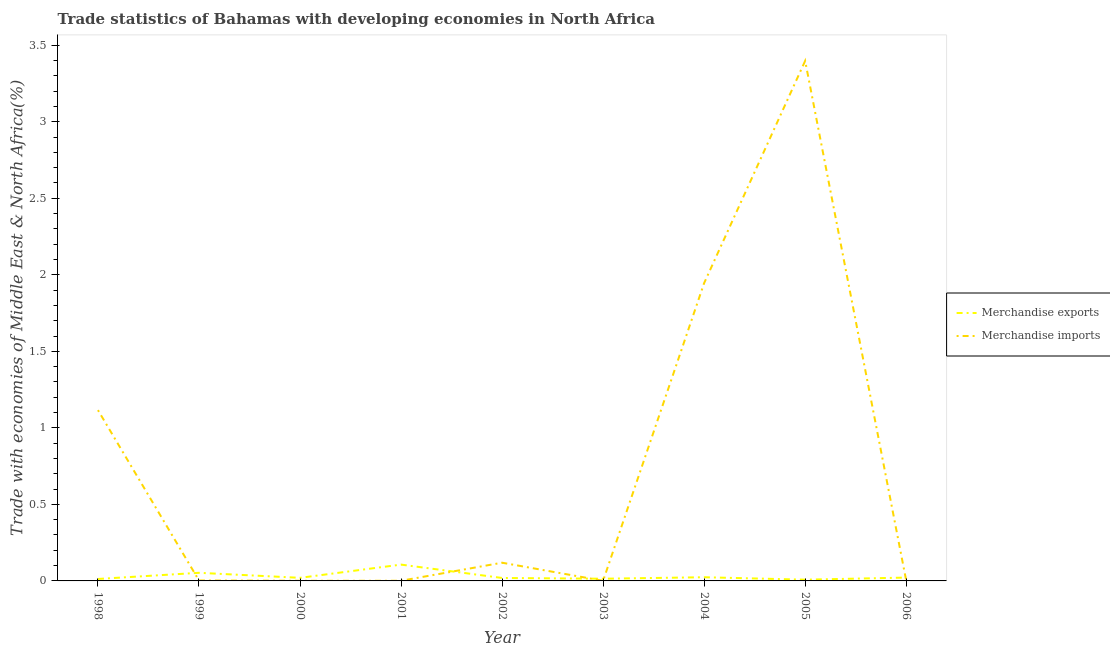How many different coloured lines are there?
Offer a very short reply. 2. What is the merchandise imports in 2002?
Offer a terse response. 0.12. Across all years, what is the maximum merchandise exports?
Your response must be concise. 0.11. Across all years, what is the minimum merchandise exports?
Offer a very short reply. 0.01. In which year was the merchandise exports minimum?
Ensure brevity in your answer.  2005. What is the total merchandise exports in the graph?
Offer a terse response. 0.28. What is the difference between the merchandise exports in 1999 and that in 2004?
Your answer should be very brief. 0.03. What is the difference between the merchandise imports in 1999 and the merchandise exports in 2004?
Keep it short and to the point. -0.02. What is the average merchandise exports per year?
Ensure brevity in your answer.  0.03. In the year 1998, what is the difference between the merchandise exports and merchandise imports?
Your answer should be compact. -1.1. What is the ratio of the merchandise imports in 2003 to that in 2005?
Keep it short and to the point. 0. Is the merchandise exports in 2000 less than that in 2002?
Keep it short and to the point. No. Is the difference between the merchandise imports in 2001 and 2006 greater than the difference between the merchandise exports in 2001 and 2006?
Make the answer very short. No. What is the difference between the highest and the second highest merchandise imports?
Offer a terse response. 1.45. What is the difference between the highest and the lowest merchandise imports?
Provide a short and direct response. 3.4. Does the merchandise exports monotonically increase over the years?
Offer a very short reply. No. Is the merchandise exports strictly greater than the merchandise imports over the years?
Keep it short and to the point. No. Is the merchandise exports strictly less than the merchandise imports over the years?
Make the answer very short. No. Are the values on the major ticks of Y-axis written in scientific E-notation?
Your answer should be compact. No. Does the graph contain any zero values?
Provide a short and direct response. No. How are the legend labels stacked?
Make the answer very short. Vertical. What is the title of the graph?
Provide a succinct answer. Trade statistics of Bahamas with developing economies in North Africa. Does "Private funds" appear as one of the legend labels in the graph?
Make the answer very short. No. What is the label or title of the Y-axis?
Your answer should be very brief. Trade with economies of Middle East & North Africa(%). What is the Trade with economies of Middle East & North Africa(%) of Merchandise exports in 1998?
Keep it short and to the point. 0.01. What is the Trade with economies of Middle East & North Africa(%) in Merchandise imports in 1998?
Provide a succinct answer. 1.12. What is the Trade with economies of Middle East & North Africa(%) of Merchandise exports in 1999?
Your response must be concise. 0.05. What is the Trade with economies of Middle East & North Africa(%) in Merchandise imports in 1999?
Keep it short and to the point. 0. What is the Trade with economies of Middle East & North Africa(%) of Merchandise exports in 2000?
Provide a short and direct response. 0.02. What is the Trade with economies of Middle East & North Africa(%) in Merchandise imports in 2000?
Make the answer very short. 0. What is the Trade with economies of Middle East & North Africa(%) in Merchandise exports in 2001?
Offer a very short reply. 0.11. What is the Trade with economies of Middle East & North Africa(%) of Merchandise imports in 2001?
Give a very brief answer. 0. What is the Trade with economies of Middle East & North Africa(%) in Merchandise exports in 2002?
Make the answer very short. 0.02. What is the Trade with economies of Middle East & North Africa(%) of Merchandise imports in 2002?
Your response must be concise. 0.12. What is the Trade with economies of Middle East & North Africa(%) of Merchandise exports in 2003?
Make the answer very short. 0.01. What is the Trade with economies of Middle East & North Africa(%) in Merchandise imports in 2003?
Provide a succinct answer. 0. What is the Trade with economies of Middle East & North Africa(%) in Merchandise exports in 2004?
Give a very brief answer. 0.02. What is the Trade with economies of Middle East & North Africa(%) in Merchandise imports in 2004?
Provide a short and direct response. 1.95. What is the Trade with economies of Middle East & North Africa(%) of Merchandise exports in 2005?
Make the answer very short. 0.01. What is the Trade with economies of Middle East & North Africa(%) of Merchandise imports in 2005?
Provide a succinct answer. 3.4. What is the Trade with economies of Middle East & North Africa(%) in Merchandise exports in 2006?
Make the answer very short. 0.02. What is the Trade with economies of Middle East & North Africa(%) of Merchandise imports in 2006?
Your response must be concise. 0. Across all years, what is the maximum Trade with economies of Middle East & North Africa(%) in Merchandise exports?
Provide a succinct answer. 0.11. Across all years, what is the maximum Trade with economies of Middle East & North Africa(%) of Merchandise imports?
Your answer should be compact. 3.4. Across all years, what is the minimum Trade with economies of Middle East & North Africa(%) in Merchandise exports?
Your answer should be very brief. 0.01. Across all years, what is the minimum Trade with economies of Middle East & North Africa(%) in Merchandise imports?
Make the answer very short. 0. What is the total Trade with economies of Middle East & North Africa(%) of Merchandise exports in the graph?
Provide a succinct answer. 0.28. What is the total Trade with economies of Middle East & North Africa(%) in Merchandise imports in the graph?
Your answer should be very brief. 6.59. What is the difference between the Trade with economies of Middle East & North Africa(%) in Merchandise exports in 1998 and that in 1999?
Provide a succinct answer. -0.04. What is the difference between the Trade with economies of Middle East & North Africa(%) in Merchandise imports in 1998 and that in 1999?
Keep it short and to the point. 1.11. What is the difference between the Trade with economies of Middle East & North Africa(%) of Merchandise exports in 1998 and that in 2000?
Your answer should be very brief. -0.01. What is the difference between the Trade with economies of Middle East & North Africa(%) in Merchandise imports in 1998 and that in 2000?
Your response must be concise. 1.11. What is the difference between the Trade with economies of Middle East & North Africa(%) in Merchandise exports in 1998 and that in 2001?
Offer a terse response. -0.09. What is the difference between the Trade with economies of Middle East & North Africa(%) of Merchandise imports in 1998 and that in 2001?
Give a very brief answer. 1.11. What is the difference between the Trade with economies of Middle East & North Africa(%) in Merchandise exports in 1998 and that in 2002?
Give a very brief answer. -0.01. What is the difference between the Trade with economies of Middle East & North Africa(%) of Merchandise exports in 1998 and that in 2003?
Offer a terse response. -0. What is the difference between the Trade with economies of Middle East & North Africa(%) in Merchandise imports in 1998 and that in 2003?
Your answer should be very brief. 1.11. What is the difference between the Trade with economies of Middle East & North Africa(%) of Merchandise exports in 1998 and that in 2004?
Provide a succinct answer. -0.01. What is the difference between the Trade with economies of Middle East & North Africa(%) in Merchandise imports in 1998 and that in 2004?
Make the answer very short. -0.83. What is the difference between the Trade with economies of Middle East & North Africa(%) in Merchandise exports in 1998 and that in 2005?
Keep it short and to the point. 0. What is the difference between the Trade with economies of Middle East & North Africa(%) in Merchandise imports in 1998 and that in 2005?
Offer a very short reply. -2.28. What is the difference between the Trade with economies of Middle East & North Africa(%) in Merchandise exports in 1998 and that in 2006?
Provide a succinct answer. -0.01. What is the difference between the Trade with economies of Middle East & North Africa(%) of Merchandise imports in 1998 and that in 2006?
Give a very brief answer. 1.11. What is the difference between the Trade with economies of Middle East & North Africa(%) in Merchandise exports in 1999 and that in 2000?
Your response must be concise. 0.03. What is the difference between the Trade with economies of Middle East & North Africa(%) of Merchandise imports in 1999 and that in 2000?
Offer a very short reply. 0. What is the difference between the Trade with economies of Middle East & North Africa(%) of Merchandise exports in 1999 and that in 2001?
Keep it short and to the point. -0.05. What is the difference between the Trade with economies of Middle East & North Africa(%) in Merchandise imports in 1999 and that in 2001?
Offer a terse response. 0. What is the difference between the Trade with economies of Middle East & North Africa(%) in Merchandise exports in 1999 and that in 2002?
Give a very brief answer. 0.03. What is the difference between the Trade with economies of Middle East & North Africa(%) in Merchandise imports in 1999 and that in 2002?
Keep it short and to the point. -0.12. What is the difference between the Trade with economies of Middle East & North Africa(%) in Merchandise exports in 1999 and that in 2003?
Keep it short and to the point. 0.04. What is the difference between the Trade with economies of Middle East & North Africa(%) of Merchandise imports in 1999 and that in 2003?
Your answer should be compact. 0. What is the difference between the Trade with economies of Middle East & North Africa(%) of Merchandise exports in 1999 and that in 2004?
Ensure brevity in your answer.  0.03. What is the difference between the Trade with economies of Middle East & North Africa(%) in Merchandise imports in 1999 and that in 2004?
Offer a very short reply. -1.94. What is the difference between the Trade with economies of Middle East & North Africa(%) of Merchandise exports in 1999 and that in 2005?
Provide a succinct answer. 0.04. What is the difference between the Trade with economies of Middle East & North Africa(%) of Merchandise imports in 1999 and that in 2005?
Make the answer very short. -3.39. What is the difference between the Trade with economies of Middle East & North Africa(%) in Merchandise exports in 1999 and that in 2006?
Give a very brief answer. 0.03. What is the difference between the Trade with economies of Middle East & North Africa(%) in Merchandise imports in 1999 and that in 2006?
Offer a terse response. -0. What is the difference between the Trade with economies of Middle East & North Africa(%) in Merchandise exports in 2000 and that in 2001?
Ensure brevity in your answer.  -0.09. What is the difference between the Trade with economies of Middle East & North Africa(%) in Merchandise imports in 2000 and that in 2001?
Provide a short and direct response. 0. What is the difference between the Trade with economies of Middle East & North Africa(%) of Merchandise exports in 2000 and that in 2002?
Your answer should be very brief. 0. What is the difference between the Trade with economies of Middle East & North Africa(%) in Merchandise imports in 2000 and that in 2002?
Keep it short and to the point. -0.12. What is the difference between the Trade with economies of Middle East & North Africa(%) of Merchandise exports in 2000 and that in 2003?
Offer a terse response. 0.01. What is the difference between the Trade with economies of Middle East & North Africa(%) of Merchandise imports in 2000 and that in 2003?
Give a very brief answer. 0. What is the difference between the Trade with economies of Middle East & North Africa(%) in Merchandise exports in 2000 and that in 2004?
Give a very brief answer. -0. What is the difference between the Trade with economies of Middle East & North Africa(%) in Merchandise imports in 2000 and that in 2004?
Your answer should be compact. -1.94. What is the difference between the Trade with economies of Middle East & North Africa(%) in Merchandise exports in 2000 and that in 2005?
Give a very brief answer. 0.01. What is the difference between the Trade with economies of Middle East & North Africa(%) of Merchandise imports in 2000 and that in 2005?
Offer a terse response. -3.4. What is the difference between the Trade with economies of Middle East & North Africa(%) of Merchandise exports in 2000 and that in 2006?
Provide a succinct answer. -0. What is the difference between the Trade with economies of Middle East & North Africa(%) in Merchandise imports in 2000 and that in 2006?
Your response must be concise. -0. What is the difference between the Trade with economies of Middle East & North Africa(%) in Merchandise exports in 2001 and that in 2002?
Your answer should be compact. 0.09. What is the difference between the Trade with economies of Middle East & North Africa(%) of Merchandise imports in 2001 and that in 2002?
Provide a short and direct response. -0.12. What is the difference between the Trade with economies of Middle East & North Africa(%) of Merchandise exports in 2001 and that in 2003?
Ensure brevity in your answer.  0.09. What is the difference between the Trade with economies of Middle East & North Africa(%) of Merchandise imports in 2001 and that in 2003?
Your response must be concise. 0. What is the difference between the Trade with economies of Middle East & North Africa(%) of Merchandise exports in 2001 and that in 2004?
Make the answer very short. 0.08. What is the difference between the Trade with economies of Middle East & North Africa(%) of Merchandise imports in 2001 and that in 2004?
Make the answer very short. -1.94. What is the difference between the Trade with economies of Middle East & North Africa(%) of Merchandise exports in 2001 and that in 2005?
Your response must be concise. 0.1. What is the difference between the Trade with economies of Middle East & North Africa(%) of Merchandise imports in 2001 and that in 2005?
Provide a succinct answer. -3.4. What is the difference between the Trade with economies of Middle East & North Africa(%) in Merchandise exports in 2001 and that in 2006?
Keep it short and to the point. 0.08. What is the difference between the Trade with economies of Middle East & North Africa(%) in Merchandise imports in 2001 and that in 2006?
Your answer should be compact. -0. What is the difference between the Trade with economies of Middle East & North Africa(%) in Merchandise exports in 2002 and that in 2003?
Your answer should be compact. 0. What is the difference between the Trade with economies of Middle East & North Africa(%) in Merchandise imports in 2002 and that in 2003?
Your answer should be very brief. 0.12. What is the difference between the Trade with economies of Middle East & North Africa(%) of Merchandise exports in 2002 and that in 2004?
Your answer should be very brief. -0. What is the difference between the Trade with economies of Middle East & North Africa(%) in Merchandise imports in 2002 and that in 2004?
Offer a terse response. -1.83. What is the difference between the Trade with economies of Middle East & North Africa(%) of Merchandise exports in 2002 and that in 2005?
Offer a very short reply. 0.01. What is the difference between the Trade with economies of Middle East & North Africa(%) of Merchandise imports in 2002 and that in 2005?
Your answer should be compact. -3.28. What is the difference between the Trade with economies of Middle East & North Africa(%) of Merchandise exports in 2002 and that in 2006?
Ensure brevity in your answer.  -0. What is the difference between the Trade with economies of Middle East & North Africa(%) of Merchandise imports in 2002 and that in 2006?
Give a very brief answer. 0.12. What is the difference between the Trade with economies of Middle East & North Africa(%) in Merchandise exports in 2003 and that in 2004?
Keep it short and to the point. -0.01. What is the difference between the Trade with economies of Middle East & North Africa(%) of Merchandise imports in 2003 and that in 2004?
Your response must be concise. -1.94. What is the difference between the Trade with economies of Middle East & North Africa(%) in Merchandise exports in 2003 and that in 2005?
Offer a terse response. 0.01. What is the difference between the Trade with economies of Middle East & North Africa(%) of Merchandise imports in 2003 and that in 2005?
Your response must be concise. -3.4. What is the difference between the Trade with economies of Middle East & North Africa(%) of Merchandise exports in 2003 and that in 2006?
Your response must be concise. -0.01. What is the difference between the Trade with economies of Middle East & North Africa(%) in Merchandise imports in 2003 and that in 2006?
Offer a terse response. -0. What is the difference between the Trade with economies of Middle East & North Africa(%) in Merchandise exports in 2004 and that in 2005?
Provide a succinct answer. 0.02. What is the difference between the Trade with economies of Middle East & North Africa(%) in Merchandise imports in 2004 and that in 2005?
Your answer should be very brief. -1.45. What is the difference between the Trade with economies of Middle East & North Africa(%) of Merchandise exports in 2004 and that in 2006?
Offer a terse response. 0. What is the difference between the Trade with economies of Middle East & North Africa(%) of Merchandise imports in 2004 and that in 2006?
Provide a succinct answer. 1.94. What is the difference between the Trade with economies of Middle East & North Africa(%) of Merchandise exports in 2005 and that in 2006?
Give a very brief answer. -0.01. What is the difference between the Trade with economies of Middle East & North Africa(%) of Merchandise imports in 2005 and that in 2006?
Your answer should be compact. 3.39. What is the difference between the Trade with economies of Middle East & North Africa(%) in Merchandise exports in 1998 and the Trade with economies of Middle East & North Africa(%) in Merchandise imports in 1999?
Keep it short and to the point. 0.01. What is the difference between the Trade with economies of Middle East & North Africa(%) in Merchandise exports in 1998 and the Trade with economies of Middle East & North Africa(%) in Merchandise imports in 2000?
Ensure brevity in your answer.  0.01. What is the difference between the Trade with economies of Middle East & North Africa(%) of Merchandise exports in 1998 and the Trade with economies of Middle East & North Africa(%) of Merchandise imports in 2001?
Your answer should be compact. 0.01. What is the difference between the Trade with economies of Middle East & North Africa(%) of Merchandise exports in 1998 and the Trade with economies of Middle East & North Africa(%) of Merchandise imports in 2002?
Provide a succinct answer. -0.11. What is the difference between the Trade with economies of Middle East & North Africa(%) of Merchandise exports in 1998 and the Trade with economies of Middle East & North Africa(%) of Merchandise imports in 2003?
Provide a succinct answer. 0.01. What is the difference between the Trade with economies of Middle East & North Africa(%) of Merchandise exports in 1998 and the Trade with economies of Middle East & North Africa(%) of Merchandise imports in 2004?
Your answer should be compact. -1.93. What is the difference between the Trade with economies of Middle East & North Africa(%) of Merchandise exports in 1998 and the Trade with economies of Middle East & North Africa(%) of Merchandise imports in 2005?
Offer a very short reply. -3.38. What is the difference between the Trade with economies of Middle East & North Africa(%) in Merchandise exports in 1998 and the Trade with economies of Middle East & North Africa(%) in Merchandise imports in 2006?
Keep it short and to the point. 0.01. What is the difference between the Trade with economies of Middle East & North Africa(%) of Merchandise exports in 1999 and the Trade with economies of Middle East & North Africa(%) of Merchandise imports in 2000?
Give a very brief answer. 0.05. What is the difference between the Trade with economies of Middle East & North Africa(%) of Merchandise exports in 1999 and the Trade with economies of Middle East & North Africa(%) of Merchandise imports in 2001?
Keep it short and to the point. 0.05. What is the difference between the Trade with economies of Middle East & North Africa(%) of Merchandise exports in 1999 and the Trade with economies of Middle East & North Africa(%) of Merchandise imports in 2002?
Offer a very short reply. -0.07. What is the difference between the Trade with economies of Middle East & North Africa(%) of Merchandise exports in 1999 and the Trade with economies of Middle East & North Africa(%) of Merchandise imports in 2003?
Your response must be concise. 0.05. What is the difference between the Trade with economies of Middle East & North Africa(%) of Merchandise exports in 1999 and the Trade with economies of Middle East & North Africa(%) of Merchandise imports in 2004?
Provide a succinct answer. -1.89. What is the difference between the Trade with economies of Middle East & North Africa(%) in Merchandise exports in 1999 and the Trade with economies of Middle East & North Africa(%) in Merchandise imports in 2005?
Offer a very short reply. -3.34. What is the difference between the Trade with economies of Middle East & North Africa(%) of Merchandise exports in 1999 and the Trade with economies of Middle East & North Africa(%) of Merchandise imports in 2006?
Offer a terse response. 0.05. What is the difference between the Trade with economies of Middle East & North Africa(%) of Merchandise exports in 2000 and the Trade with economies of Middle East & North Africa(%) of Merchandise imports in 2001?
Keep it short and to the point. 0.02. What is the difference between the Trade with economies of Middle East & North Africa(%) in Merchandise exports in 2000 and the Trade with economies of Middle East & North Africa(%) in Merchandise imports in 2002?
Give a very brief answer. -0.1. What is the difference between the Trade with economies of Middle East & North Africa(%) in Merchandise exports in 2000 and the Trade with economies of Middle East & North Africa(%) in Merchandise imports in 2003?
Offer a very short reply. 0.02. What is the difference between the Trade with economies of Middle East & North Africa(%) of Merchandise exports in 2000 and the Trade with economies of Middle East & North Africa(%) of Merchandise imports in 2004?
Keep it short and to the point. -1.93. What is the difference between the Trade with economies of Middle East & North Africa(%) in Merchandise exports in 2000 and the Trade with economies of Middle East & North Africa(%) in Merchandise imports in 2005?
Provide a short and direct response. -3.38. What is the difference between the Trade with economies of Middle East & North Africa(%) in Merchandise exports in 2000 and the Trade with economies of Middle East & North Africa(%) in Merchandise imports in 2006?
Your answer should be compact. 0.02. What is the difference between the Trade with economies of Middle East & North Africa(%) of Merchandise exports in 2001 and the Trade with economies of Middle East & North Africa(%) of Merchandise imports in 2002?
Offer a terse response. -0.01. What is the difference between the Trade with economies of Middle East & North Africa(%) of Merchandise exports in 2001 and the Trade with economies of Middle East & North Africa(%) of Merchandise imports in 2003?
Your answer should be very brief. 0.11. What is the difference between the Trade with economies of Middle East & North Africa(%) in Merchandise exports in 2001 and the Trade with economies of Middle East & North Africa(%) in Merchandise imports in 2004?
Make the answer very short. -1.84. What is the difference between the Trade with economies of Middle East & North Africa(%) of Merchandise exports in 2001 and the Trade with economies of Middle East & North Africa(%) of Merchandise imports in 2005?
Keep it short and to the point. -3.29. What is the difference between the Trade with economies of Middle East & North Africa(%) of Merchandise exports in 2001 and the Trade with economies of Middle East & North Africa(%) of Merchandise imports in 2006?
Keep it short and to the point. 0.1. What is the difference between the Trade with economies of Middle East & North Africa(%) of Merchandise exports in 2002 and the Trade with economies of Middle East & North Africa(%) of Merchandise imports in 2003?
Provide a succinct answer. 0.02. What is the difference between the Trade with economies of Middle East & North Africa(%) in Merchandise exports in 2002 and the Trade with economies of Middle East & North Africa(%) in Merchandise imports in 2004?
Your answer should be very brief. -1.93. What is the difference between the Trade with economies of Middle East & North Africa(%) of Merchandise exports in 2002 and the Trade with economies of Middle East & North Africa(%) of Merchandise imports in 2005?
Offer a terse response. -3.38. What is the difference between the Trade with economies of Middle East & North Africa(%) in Merchandise exports in 2002 and the Trade with economies of Middle East & North Africa(%) in Merchandise imports in 2006?
Provide a succinct answer. 0.02. What is the difference between the Trade with economies of Middle East & North Africa(%) in Merchandise exports in 2003 and the Trade with economies of Middle East & North Africa(%) in Merchandise imports in 2004?
Provide a short and direct response. -1.93. What is the difference between the Trade with economies of Middle East & North Africa(%) of Merchandise exports in 2003 and the Trade with economies of Middle East & North Africa(%) of Merchandise imports in 2005?
Offer a very short reply. -3.38. What is the difference between the Trade with economies of Middle East & North Africa(%) in Merchandise exports in 2003 and the Trade with economies of Middle East & North Africa(%) in Merchandise imports in 2006?
Keep it short and to the point. 0.01. What is the difference between the Trade with economies of Middle East & North Africa(%) in Merchandise exports in 2004 and the Trade with economies of Middle East & North Africa(%) in Merchandise imports in 2005?
Your answer should be compact. -3.37. What is the difference between the Trade with economies of Middle East & North Africa(%) in Merchandise exports in 2004 and the Trade with economies of Middle East & North Africa(%) in Merchandise imports in 2006?
Offer a very short reply. 0.02. What is the difference between the Trade with economies of Middle East & North Africa(%) in Merchandise exports in 2005 and the Trade with economies of Middle East & North Africa(%) in Merchandise imports in 2006?
Your answer should be compact. 0.01. What is the average Trade with economies of Middle East & North Africa(%) of Merchandise exports per year?
Your response must be concise. 0.03. What is the average Trade with economies of Middle East & North Africa(%) in Merchandise imports per year?
Offer a very short reply. 0.73. In the year 1998, what is the difference between the Trade with economies of Middle East & North Africa(%) of Merchandise exports and Trade with economies of Middle East & North Africa(%) of Merchandise imports?
Offer a very short reply. -1.1. In the year 1999, what is the difference between the Trade with economies of Middle East & North Africa(%) in Merchandise exports and Trade with economies of Middle East & North Africa(%) in Merchandise imports?
Give a very brief answer. 0.05. In the year 2000, what is the difference between the Trade with economies of Middle East & North Africa(%) in Merchandise exports and Trade with economies of Middle East & North Africa(%) in Merchandise imports?
Your answer should be compact. 0.02. In the year 2001, what is the difference between the Trade with economies of Middle East & North Africa(%) in Merchandise exports and Trade with economies of Middle East & North Africa(%) in Merchandise imports?
Ensure brevity in your answer.  0.11. In the year 2002, what is the difference between the Trade with economies of Middle East & North Africa(%) in Merchandise exports and Trade with economies of Middle East & North Africa(%) in Merchandise imports?
Provide a succinct answer. -0.1. In the year 2003, what is the difference between the Trade with economies of Middle East & North Africa(%) of Merchandise exports and Trade with economies of Middle East & North Africa(%) of Merchandise imports?
Ensure brevity in your answer.  0.01. In the year 2004, what is the difference between the Trade with economies of Middle East & North Africa(%) in Merchandise exports and Trade with economies of Middle East & North Africa(%) in Merchandise imports?
Offer a very short reply. -1.92. In the year 2005, what is the difference between the Trade with economies of Middle East & North Africa(%) of Merchandise exports and Trade with economies of Middle East & North Africa(%) of Merchandise imports?
Provide a short and direct response. -3.39. In the year 2006, what is the difference between the Trade with economies of Middle East & North Africa(%) of Merchandise exports and Trade with economies of Middle East & North Africa(%) of Merchandise imports?
Your answer should be very brief. 0.02. What is the ratio of the Trade with economies of Middle East & North Africa(%) in Merchandise exports in 1998 to that in 1999?
Your response must be concise. 0.24. What is the ratio of the Trade with economies of Middle East & North Africa(%) in Merchandise imports in 1998 to that in 1999?
Your answer should be very brief. 386.59. What is the ratio of the Trade with economies of Middle East & North Africa(%) of Merchandise exports in 1998 to that in 2000?
Keep it short and to the point. 0.63. What is the ratio of the Trade with economies of Middle East & North Africa(%) in Merchandise imports in 1998 to that in 2000?
Your response must be concise. 1082.91. What is the ratio of the Trade with economies of Middle East & North Africa(%) in Merchandise exports in 1998 to that in 2001?
Your response must be concise. 0.12. What is the ratio of the Trade with economies of Middle East & North Africa(%) of Merchandise imports in 1998 to that in 2001?
Offer a terse response. 1092.65. What is the ratio of the Trade with economies of Middle East & North Africa(%) in Merchandise exports in 1998 to that in 2002?
Your answer should be compact. 0.66. What is the ratio of the Trade with economies of Middle East & North Africa(%) in Merchandise imports in 1998 to that in 2002?
Provide a succinct answer. 9.37. What is the ratio of the Trade with economies of Middle East & North Africa(%) of Merchandise exports in 1998 to that in 2003?
Provide a short and direct response. 0.89. What is the ratio of the Trade with economies of Middle East & North Africa(%) in Merchandise imports in 1998 to that in 2003?
Keep it short and to the point. 1392.96. What is the ratio of the Trade with economies of Middle East & North Africa(%) in Merchandise exports in 1998 to that in 2004?
Offer a very short reply. 0.53. What is the ratio of the Trade with economies of Middle East & North Africa(%) in Merchandise imports in 1998 to that in 2004?
Offer a very short reply. 0.57. What is the ratio of the Trade with economies of Middle East & North Africa(%) in Merchandise exports in 1998 to that in 2005?
Keep it short and to the point. 1.57. What is the ratio of the Trade with economies of Middle East & North Africa(%) in Merchandise imports in 1998 to that in 2005?
Keep it short and to the point. 0.33. What is the ratio of the Trade with economies of Middle East & North Africa(%) of Merchandise exports in 1998 to that in 2006?
Give a very brief answer. 0.59. What is the ratio of the Trade with economies of Middle East & North Africa(%) of Merchandise imports in 1998 to that in 2006?
Provide a succinct answer. 374.2. What is the ratio of the Trade with economies of Middle East & North Africa(%) of Merchandise exports in 1999 to that in 2000?
Keep it short and to the point. 2.63. What is the ratio of the Trade with economies of Middle East & North Africa(%) in Merchandise imports in 1999 to that in 2000?
Offer a terse response. 2.8. What is the ratio of the Trade with economies of Middle East & North Africa(%) in Merchandise exports in 1999 to that in 2001?
Provide a short and direct response. 0.5. What is the ratio of the Trade with economies of Middle East & North Africa(%) in Merchandise imports in 1999 to that in 2001?
Give a very brief answer. 2.83. What is the ratio of the Trade with economies of Middle East & North Africa(%) in Merchandise exports in 1999 to that in 2002?
Provide a succinct answer. 2.75. What is the ratio of the Trade with economies of Middle East & North Africa(%) of Merchandise imports in 1999 to that in 2002?
Offer a terse response. 0.02. What is the ratio of the Trade with economies of Middle East & North Africa(%) in Merchandise exports in 1999 to that in 2003?
Your answer should be very brief. 3.7. What is the ratio of the Trade with economies of Middle East & North Africa(%) in Merchandise imports in 1999 to that in 2003?
Your answer should be very brief. 3.6. What is the ratio of the Trade with economies of Middle East & North Africa(%) of Merchandise exports in 1999 to that in 2004?
Your answer should be very brief. 2.2. What is the ratio of the Trade with economies of Middle East & North Africa(%) in Merchandise imports in 1999 to that in 2004?
Your answer should be very brief. 0. What is the ratio of the Trade with economies of Middle East & North Africa(%) of Merchandise exports in 1999 to that in 2005?
Keep it short and to the point. 6.51. What is the ratio of the Trade with economies of Middle East & North Africa(%) of Merchandise imports in 1999 to that in 2005?
Your response must be concise. 0. What is the ratio of the Trade with economies of Middle East & North Africa(%) of Merchandise exports in 1999 to that in 2006?
Offer a very short reply. 2.43. What is the ratio of the Trade with economies of Middle East & North Africa(%) of Merchandise imports in 1999 to that in 2006?
Make the answer very short. 0.97. What is the ratio of the Trade with economies of Middle East & North Africa(%) of Merchandise exports in 2000 to that in 2001?
Keep it short and to the point. 0.19. What is the ratio of the Trade with economies of Middle East & North Africa(%) in Merchandise imports in 2000 to that in 2001?
Keep it short and to the point. 1.01. What is the ratio of the Trade with economies of Middle East & North Africa(%) of Merchandise exports in 2000 to that in 2002?
Offer a very short reply. 1.05. What is the ratio of the Trade with economies of Middle East & North Africa(%) of Merchandise imports in 2000 to that in 2002?
Offer a very short reply. 0.01. What is the ratio of the Trade with economies of Middle East & North Africa(%) in Merchandise exports in 2000 to that in 2003?
Provide a succinct answer. 1.41. What is the ratio of the Trade with economies of Middle East & North Africa(%) of Merchandise imports in 2000 to that in 2003?
Provide a short and direct response. 1.29. What is the ratio of the Trade with economies of Middle East & North Africa(%) in Merchandise exports in 2000 to that in 2004?
Give a very brief answer. 0.84. What is the ratio of the Trade with economies of Middle East & North Africa(%) of Merchandise imports in 2000 to that in 2004?
Give a very brief answer. 0. What is the ratio of the Trade with economies of Middle East & North Africa(%) of Merchandise exports in 2000 to that in 2005?
Your answer should be very brief. 2.48. What is the ratio of the Trade with economies of Middle East & North Africa(%) of Merchandise exports in 2000 to that in 2006?
Ensure brevity in your answer.  0.93. What is the ratio of the Trade with economies of Middle East & North Africa(%) in Merchandise imports in 2000 to that in 2006?
Make the answer very short. 0.35. What is the ratio of the Trade with economies of Middle East & North Africa(%) in Merchandise exports in 2001 to that in 2002?
Offer a very short reply. 5.53. What is the ratio of the Trade with economies of Middle East & North Africa(%) in Merchandise imports in 2001 to that in 2002?
Your response must be concise. 0.01. What is the ratio of the Trade with economies of Middle East & North Africa(%) of Merchandise exports in 2001 to that in 2003?
Your answer should be compact. 7.43. What is the ratio of the Trade with economies of Middle East & North Africa(%) in Merchandise imports in 2001 to that in 2003?
Provide a succinct answer. 1.27. What is the ratio of the Trade with economies of Middle East & North Africa(%) in Merchandise exports in 2001 to that in 2004?
Provide a succinct answer. 4.43. What is the ratio of the Trade with economies of Middle East & North Africa(%) in Merchandise exports in 2001 to that in 2005?
Give a very brief answer. 13.08. What is the ratio of the Trade with economies of Middle East & North Africa(%) of Merchandise imports in 2001 to that in 2005?
Provide a short and direct response. 0. What is the ratio of the Trade with economies of Middle East & North Africa(%) of Merchandise exports in 2001 to that in 2006?
Ensure brevity in your answer.  4.89. What is the ratio of the Trade with economies of Middle East & North Africa(%) in Merchandise imports in 2001 to that in 2006?
Your answer should be compact. 0.34. What is the ratio of the Trade with economies of Middle East & North Africa(%) of Merchandise exports in 2002 to that in 2003?
Provide a short and direct response. 1.34. What is the ratio of the Trade with economies of Middle East & North Africa(%) in Merchandise imports in 2002 to that in 2003?
Keep it short and to the point. 148.63. What is the ratio of the Trade with economies of Middle East & North Africa(%) of Merchandise exports in 2002 to that in 2004?
Provide a succinct answer. 0.8. What is the ratio of the Trade with economies of Middle East & North Africa(%) of Merchandise imports in 2002 to that in 2004?
Make the answer very short. 0.06. What is the ratio of the Trade with economies of Middle East & North Africa(%) in Merchandise exports in 2002 to that in 2005?
Provide a succinct answer. 2.37. What is the ratio of the Trade with economies of Middle East & North Africa(%) in Merchandise imports in 2002 to that in 2005?
Your answer should be compact. 0.04. What is the ratio of the Trade with economies of Middle East & North Africa(%) of Merchandise exports in 2002 to that in 2006?
Your response must be concise. 0.88. What is the ratio of the Trade with economies of Middle East & North Africa(%) of Merchandise imports in 2002 to that in 2006?
Offer a terse response. 39.93. What is the ratio of the Trade with economies of Middle East & North Africa(%) of Merchandise exports in 2003 to that in 2004?
Provide a succinct answer. 0.6. What is the ratio of the Trade with economies of Middle East & North Africa(%) in Merchandise exports in 2003 to that in 2005?
Offer a very short reply. 1.76. What is the ratio of the Trade with economies of Middle East & North Africa(%) in Merchandise imports in 2003 to that in 2005?
Provide a succinct answer. 0. What is the ratio of the Trade with economies of Middle East & North Africa(%) of Merchandise exports in 2003 to that in 2006?
Provide a short and direct response. 0.66. What is the ratio of the Trade with economies of Middle East & North Africa(%) in Merchandise imports in 2003 to that in 2006?
Offer a very short reply. 0.27. What is the ratio of the Trade with economies of Middle East & North Africa(%) in Merchandise exports in 2004 to that in 2005?
Make the answer very short. 2.95. What is the ratio of the Trade with economies of Middle East & North Africa(%) in Merchandise imports in 2004 to that in 2005?
Offer a very short reply. 0.57. What is the ratio of the Trade with economies of Middle East & North Africa(%) of Merchandise exports in 2004 to that in 2006?
Your response must be concise. 1.1. What is the ratio of the Trade with economies of Middle East & North Africa(%) in Merchandise imports in 2004 to that in 2006?
Offer a terse response. 652.46. What is the ratio of the Trade with economies of Middle East & North Africa(%) in Merchandise exports in 2005 to that in 2006?
Your response must be concise. 0.37. What is the ratio of the Trade with economies of Middle East & North Africa(%) of Merchandise imports in 2005 to that in 2006?
Provide a succinct answer. 1139.3. What is the difference between the highest and the second highest Trade with economies of Middle East & North Africa(%) of Merchandise exports?
Make the answer very short. 0.05. What is the difference between the highest and the second highest Trade with economies of Middle East & North Africa(%) of Merchandise imports?
Provide a short and direct response. 1.45. What is the difference between the highest and the lowest Trade with economies of Middle East & North Africa(%) in Merchandise exports?
Give a very brief answer. 0.1. What is the difference between the highest and the lowest Trade with economies of Middle East & North Africa(%) in Merchandise imports?
Ensure brevity in your answer.  3.4. 